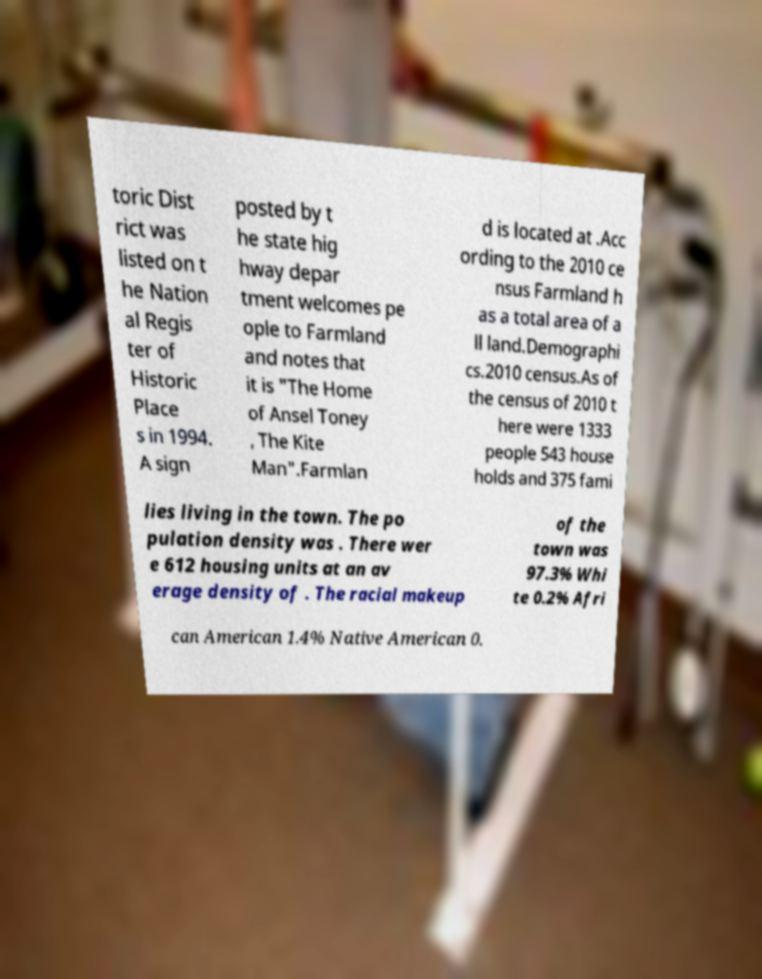Could you extract and type out the text from this image? toric Dist rict was listed on t he Nation al Regis ter of Historic Place s in 1994. A sign posted by t he state hig hway depar tment welcomes pe ople to Farmland and notes that it is "The Home of Ansel Toney , The Kite Man".Farmlan d is located at .Acc ording to the 2010 ce nsus Farmland h as a total area of a ll land.Demographi cs.2010 census.As of the census of 2010 t here were 1333 people 543 house holds and 375 fami lies living in the town. The po pulation density was . There wer e 612 housing units at an av erage density of . The racial makeup of the town was 97.3% Whi te 0.2% Afri can American 1.4% Native American 0. 